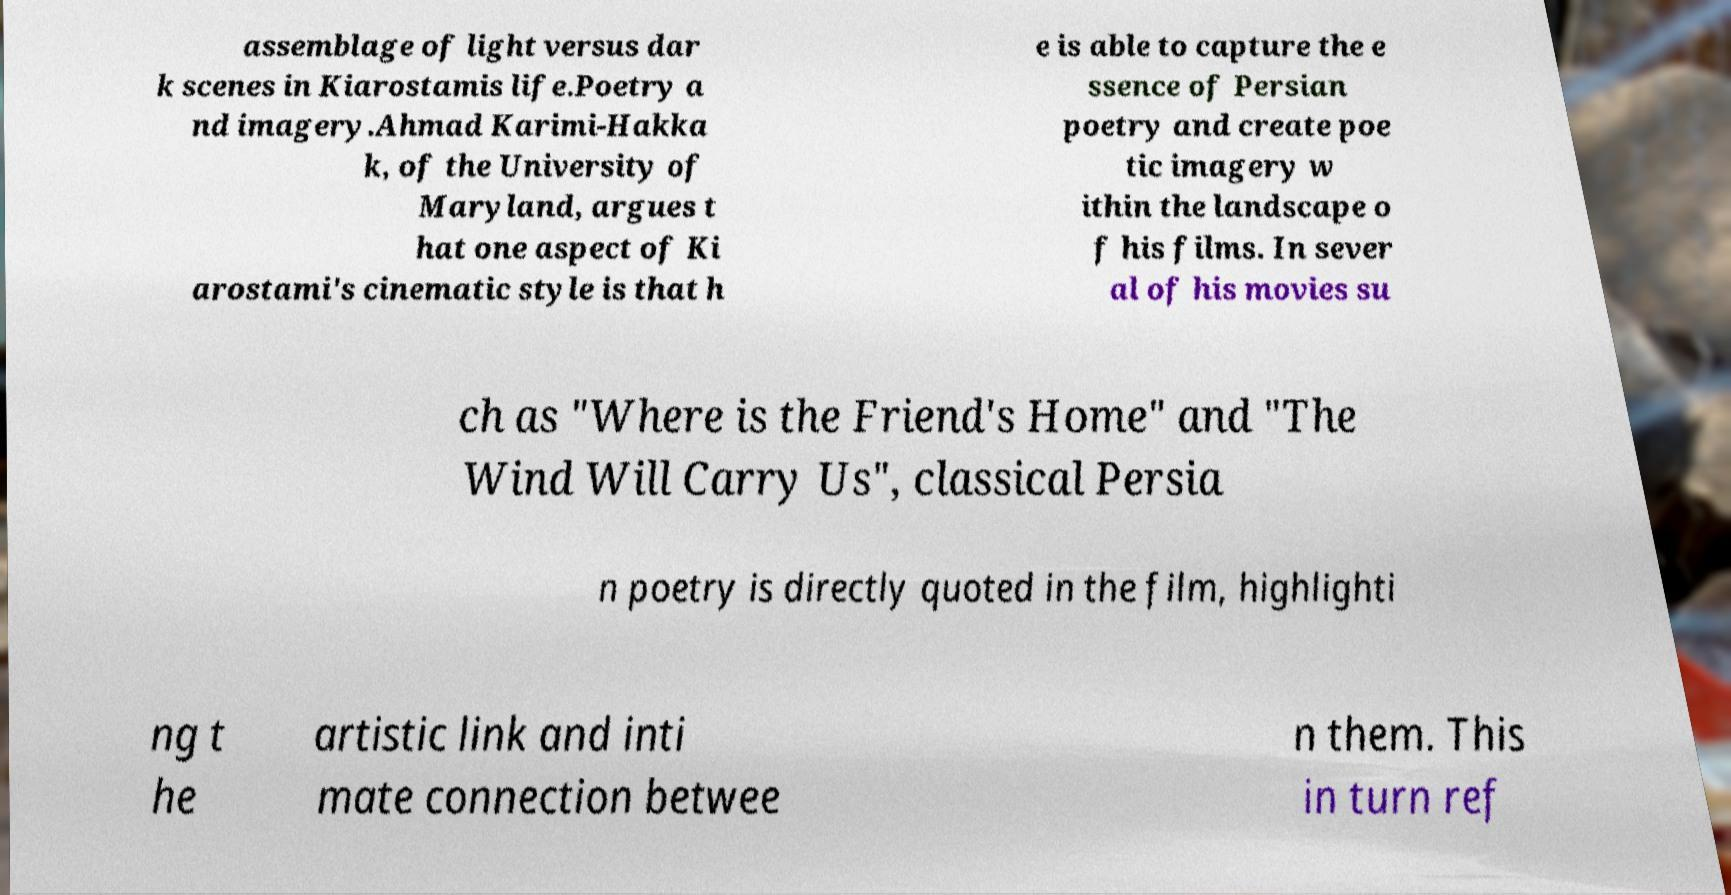Can you read and provide the text displayed in the image?This photo seems to have some interesting text. Can you extract and type it out for me? assemblage of light versus dar k scenes in Kiarostamis life.Poetry a nd imagery.Ahmad Karimi-Hakka k, of the University of Maryland, argues t hat one aspect of Ki arostami's cinematic style is that h e is able to capture the e ssence of Persian poetry and create poe tic imagery w ithin the landscape o f his films. In sever al of his movies su ch as "Where is the Friend's Home" and "The Wind Will Carry Us", classical Persia n poetry is directly quoted in the film, highlighti ng t he artistic link and inti mate connection betwee n them. This in turn ref 